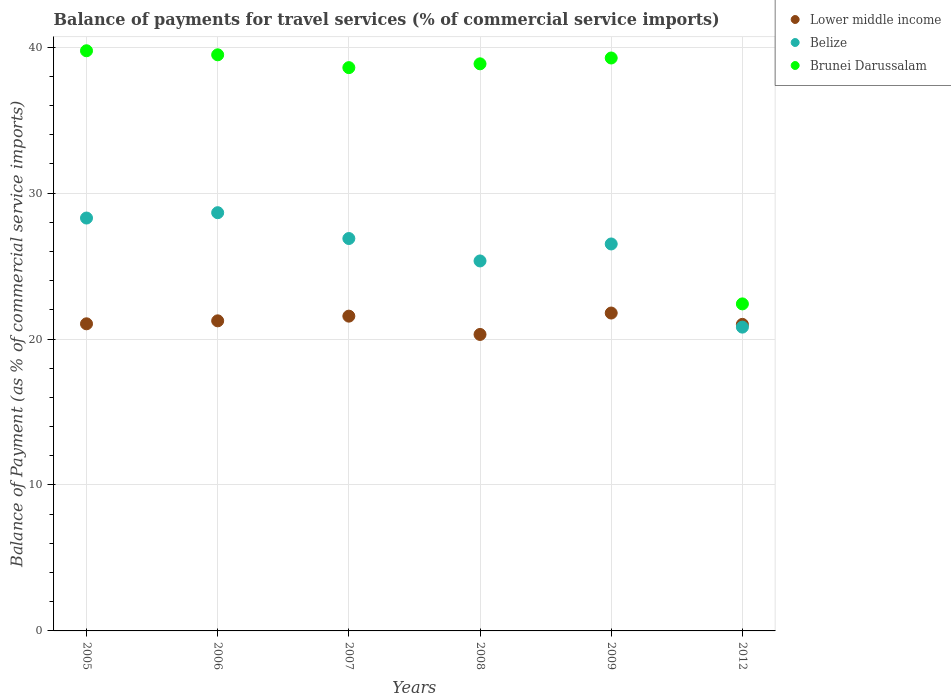How many different coloured dotlines are there?
Make the answer very short. 3. What is the balance of payments for travel services in Brunei Darussalam in 2012?
Offer a terse response. 22.41. Across all years, what is the maximum balance of payments for travel services in Belize?
Your response must be concise. 28.66. Across all years, what is the minimum balance of payments for travel services in Lower middle income?
Provide a short and direct response. 20.31. In which year was the balance of payments for travel services in Brunei Darussalam minimum?
Give a very brief answer. 2012. What is the total balance of payments for travel services in Lower middle income in the graph?
Ensure brevity in your answer.  126.95. What is the difference between the balance of payments for travel services in Lower middle income in 2005 and that in 2008?
Your answer should be very brief. 0.73. What is the difference between the balance of payments for travel services in Brunei Darussalam in 2005 and the balance of payments for travel services in Belize in 2009?
Your answer should be very brief. 13.24. What is the average balance of payments for travel services in Brunei Darussalam per year?
Provide a succinct answer. 36.39. In the year 2009, what is the difference between the balance of payments for travel services in Belize and balance of payments for travel services in Lower middle income?
Give a very brief answer. 4.73. In how many years, is the balance of payments for travel services in Lower middle income greater than 26 %?
Offer a terse response. 0. What is the ratio of the balance of payments for travel services in Brunei Darussalam in 2005 to that in 2009?
Offer a terse response. 1.01. Is the balance of payments for travel services in Lower middle income in 2007 less than that in 2012?
Your answer should be very brief. No. What is the difference between the highest and the second highest balance of payments for travel services in Belize?
Ensure brevity in your answer.  0.37. What is the difference between the highest and the lowest balance of payments for travel services in Belize?
Keep it short and to the point. 7.84. In how many years, is the balance of payments for travel services in Brunei Darussalam greater than the average balance of payments for travel services in Brunei Darussalam taken over all years?
Keep it short and to the point. 5. Is the sum of the balance of payments for travel services in Lower middle income in 2007 and 2008 greater than the maximum balance of payments for travel services in Belize across all years?
Ensure brevity in your answer.  Yes. Is the balance of payments for travel services in Belize strictly greater than the balance of payments for travel services in Brunei Darussalam over the years?
Offer a very short reply. No. Is the balance of payments for travel services in Lower middle income strictly less than the balance of payments for travel services in Belize over the years?
Make the answer very short. No. How many years are there in the graph?
Your response must be concise. 6. Does the graph contain any zero values?
Your response must be concise. No. Does the graph contain grids?
Give a very brief answer. Yes. Where does the legend appear in the graph?
Offer a very short reply. Top right. What is the title of the graph?
Offer a very short reply. Balance of payments for travel services (% of commercial service imports). Does "Switzerland" appear as one of the legend labels in the graph?
Give a very brief answer. No. What is the label or title of the Y-axis?
Provide a succinct answer. Balance of Payment (as % of commercial service imports). What is the Balance of Payment (as % of commercial service imports) of Lower middle income in 2005?
Offer a terse response. 21.04. What is the Balance of Payment (as % of commercial service imports) in Belize in 2005?
Provide a short and direct response. 28.29. What is the Balance of Payment (as % of commercial service imports) of Brunei Darussalam in 2005?
Make the answer very short. 39.75. What is the Balance of Payment (as % of commercial service imports) of Lower middle income in 2006?
Your answer should be very brief. 21.25. What is the Balance of Payment (as % of commercial service imports) of Belize in 2006?
Your answer should be very brief. 28.66. What is the Balance of Payment (as % of commercial service imports) of Brunei Darussalam in 2006?
Ensure brevity in your answer.  39.47. What is the Balance of Payment (as % of commercial service imports) in Lower middle income in 2007?
Keep it short and to the point. 21.57. What is the Balance of Payment (as % of commercial service imports) in Belize in 2007?
Your response must be concise. 26.89. What is the Balance of Payment (as % of commercial service imports) in Brunei Darussalam in 2007?
Keep it short and to the point. 38.59. What is the Balance of Payment (as % of commercial service imports) of Lower middle income in 2008?
Provide a short and direct response. 20.31. What is the Balance of Payment (as % of commercial service imports) of Belize in 2008?
Ensure brevity in your answer.  25.35. What is the Balance of Payment (as % of commercial service imports) in Brunei Darussalam in 2008?
Your answer should be compact. 38.86. What is the Balance of Payment (as % of commercial service imports) in Lower middle income in 2009?
Ensure brevity in your answer.  21.78. What is the Balance of Payment (as % of commercial service imports) in Belize in 2009?
Give a very brief answer. 26.51. What is the Balance of Payment (as % of commercial service imports) in Brunei Darussalam in 2009?
Your answer should be very brief. 39.25. What is the Balance of Payment (as % of commercial service imports) of Lower middle income in 2012?
Provide a succinct answer. 21. What is the Balance of Payment (as % of commercial service imports) of Belize in 2012?
Give a very brief answer. 20.82. What is the Balance of Payment (as % of commercial service imports) in Brunei Darussalam in 2012?
Your answer should be compact. 22.41. Across all years, what is the maximum Balance of Payment (as % of commercial service imports) in Lower middle income?
Make the answer very short. 21.78. Across all years, what is the maximum Balance of Payment (as % of commercial service imports) in Belize?
Provide a succinct answer. 28.66. Across all years, what is the maximum Balance of Payment (as % of commercial service imports) in Brunei Darussalam?
Your response must be concise. 39.75. Across all years, what is the minimum Balance of Payment (as % of commercial service imports) of Lower middle income?
Ensure brevity in your answer.  20.31. Across all years, what is the minimum Balance of Payment (as % of commercial service imports) in Belize?
Keep it short and to the point. 20.82. Across all years, what is the minimum Balance of Payment (as % of commercial service imports) of Brunei Darussalam?
Keep it short and to the point. 22.41. What is the total Balance of Payment (as % of commercial service imports) in Lower middle income in the graph?
Offer a terse response. 126.95. What is the total Balance of Payment (as % of commercial service imports) in Belize in the graph?
Your response must be concise. 156.51. What is the total Balance of Payment (as % of commercial service imports) of Brunei Darussalam in the graph?
Offer a terse response. 218.34. What is the difference between the Balance of Payment (as % of commercial service imports) of Lower middle income in 2005 and that in 2006?
Ensure brevity in your answer.  -0.2. What is the difference between the Balance of Payment (as % of commercial service imports) in Belize in 2005 and that in 2006?
Make the answer very short. -0.37. What is the difference between the Balance of Payment (as % of commercial service imports) of Brunei Darussalam in 2005 and that in 2006?
Keep it short and to the point. 0.28. What is the difference between the Balance of Payment (as % of commercial service imports) of Lower middle income in 2005 and that in 2007?
Provide a short and direct response. -0.53. What is the difference between the Balance of Payment (as % of commercial service imports) in Belize in 2005 and that in 2007?
Your response must be concise. 1.4. What is the difference between the Balance of Payment (as % of commercial service imports) in Brunei Darussalam in 2005 and that in 2007?
Your answer should be compact. 1.16. What is the difference between the Balance of Payment (as % of commercial service imports) in Lower middle income in 2005 and that in 2008?
Provide a succinct answer. 0.73. What is the difference between the Balance of Payment (as % of commercial service imports) of Belize in 2005 and that in 2008?
Your answer should be very brief. 2.94. What is the difference between the Balance of Payment (as % of commercial service imports) in Brunei Darussalam in 2005 and that in 2008?
Ensure brevity in your answer.  0.9. What is the difference between the Balance of Payment (as % of commercial service imports) in Lower middle income in 2005 and that in 2009?
Your answer should be compact. -0.74. What is the difference between the Balance of Payment (as % of commercial service imports) in Belize in 2005 and that in 2009?
Keep it short and to the point. 1.78. What is the difference between the Balance of Payment (as % of commercial service imports) of Brunei Darussalam in 2005 and that in 2009?
Provide a short and direct response. 0.5. What is the difference between the Balance of Payment (as % of commercial service imports) in Lower middle income in 2005 and that in 2012?
Your answer should be very brief. 0.04. What is the difference between the Balance of Payment (as % of commercial service imports) of Belize in 2005 and that in 2012?
Give a very brief answer. 7.47. What is the difference between the Balance of Payment (as % of commercial service imports) in Brunei Darussalam in 2005 and that in 2012?
Make the answer very short. 17.34. What is the difference between the Balance of Payment (as % of commercial service imports) in Lower middle income in 2006 and that in 2007?
Your answer should be very brief. -0.32. What is the difference between the Balance of Payment (as % of commercial service imports) of Belize in 2006 and that in 2007?
Provide a succinct answer. 1.77. What is the difference between the Balance of Payment (as % of commercial service imports) of Brunei Darussalam in 2006 and that in 2007?
Ensure brevity in your answer.  0.88. What is the difference between the Balance of Payment (as % of commercial service imports) in Lower middle income in 2006 and that in 2008?
Keep it short and to the point. 0.93. What is the difference between the Balance of Payment (as % of commercial service imports) in Belize in 2006 and that in 2008?
Offer a very short reply. 3.31. What is the difference between the Balance of Payment (as % of commercial service imports) in Brunei Darussalam in 2006 and that in 2008?
Offer a terse response. 0.62. What is the difference between the Balance of Payment (as % of commercial service imports) of Lower middle income in 2006 and that in 2009?
Keep it short and to the point. -0.53. What is the difference between the Balance of Payment (as % of commercial service imports) of Belize in 2006 and that in 2009?
Offer a terse response. 2.14. What is the difference between the Balance of Payment (as % of commercial service imports) in Brunei Darussalam in 2006 and that in 2009?
Keep it short and to the point. 0.22. What is the difference between the Balance of Payment (as % of commercial service imports) in Lower middle income in 2006 and that in 2012?
Offer a very short reply. 0.24. What is the difference between the Balance of Payment (as % of commercial service imports) of Belize in 2006 and that in 2012?
Make the answer very short. 7.84. What is the difference between the Balance of Payment (as % of commercial service imports) in Brunei Darussalam in 2006 and that in 2012?
Keep it short and to the point. 17.07. What is the difference between the Balance of Payment (as % of commercial service imports) of Lower middle income in 2007 and that in 2008?
Ensure brevity in your answer.  1.25. What is the difference between the Balance of Payment (as % of commercial service imports) in Belize in 2007 and that in 2008?
Offer a terse response. 1.54. What is the difference between the Balance of Payment (as % of commercial service imports) of Brunei Darussalam in 2007 and that in 2008?
Ensure brevity in your answer.  -0.26. What is the difference between the Balance of Payment (as % of commercial service imports) in Lower middle income in 2007 and that in 2009?
Ensure brevity in your answer.  -0.21. What is the difference between the Balance of Payment (as % of commercial service imports) of Belize in 2007 and that in 2009?
Offer a terse response. 0.37. What is the difference between the Balance of Payment (as % of commercial service imports) in Brunei Darussalam in 2007 and that in 2009?
Your answer should be compact. -0.66. What is the difference between the Balance of Payment (as % of commercial service imports) in Lower middle income in 2007 and that in 2012?
Your answer should be compact. 0.56. What is the difference between the Balance of Payment (as % of commercial service imports) in Belize in 2007 and that in 2012?
Provide a short and direct response. 6.07. What is the difference between the Balance of Payment (as % of commercial service imports) of Brunei Darussalam in 2007 and that in 2012?
Make the answer very short. 16.19. What is the difference between the Balance of Payment (as % of commercial service imports) of Lower middle income in 2008 and that in 2009?
Keep it short and to the point. -1.47. What is the difference between the Balance of Payment (as % of commercial service imports) of Belize in 2008 and that in 2009?
Ensure brevity in your answer.  -1.16. What is the difference between the Balance of Payment (as % of commercial service imports) in Brunei Darussalam in 2008 and that in 2009?
Provide a short and direct response. -0.4. What is the difference between the Balance of Payment (as % of commercial service imports) in Lower middle income in 2008 and that in 2012?
Offer a very short reply. -0.69. What is the difference between the Balance of Payment (as % of commercial service imports) in Belize in 2008 and that in 2012?
Offer a terse response. 4.53. What is the difference between the Balance of Payment (as % of commercial service imports) of Brunei Darussalam in 2008 and that in 2012?
Your response must be concise. 16.45. What is the difference between the Balance of Payment (as % of commercial service imports) in Lower middle income in 2009 and that in 2012?
Your answer should be very brief. 0.78. What is the difference between the Balance of Payment (as % of commercial service imports) of Belize in 2009 and that in 2012?
Give a very brief answer. 5.7. What is the difference between the Balance of Payment (as % of commercial service imports) of Brunei Darussalam in 2009 and that in 2012?
Your answer should be very brief. 16.85. What is the difference between the Balance of Payment (as % of commercial service imports) of Lower middle income in 2005 and the Balance of Payment (as % of commercial service imports) of Belize in 2006?
Provide a succinct answer. -7.61. What is the difference between the Balance of Payment (as % of commercial service imports) in Lower middle income in 2005 and the Balance of Payment (as % of commercial service imports) in Brunei Darussalam in 2006?
Your response must be concise. -18.43. What is the difference between the Balance of Payment (as % of commercial service imports) of Belize in 2005 and the Balance of Payment (as % of commercial service imports) of Brunei Darussalam in 2006?
Make the answer very short. -11.18. What is the difference between the Balance of Payment (as % of commercial service imports) of Lower middle income in 2005 and the Balance of Payment (as % of commercial service imports) of Belize in 2007?
Your response must be concise. -5.84. What is the difference between the Balance of Payment (as % of commercial service imports) in Lower middle income in 2005 and the Balance of Payment (as % of commercial service imports) in Brunei Darussalam in 2007?
Your answer should be compact. -17.55. What is the difference between the Balance of Payment (as % of commercial service imports) in Belize in 2005 and the Balance of Payment (as % of commercial service imports) in Brunei Darussalam in 2007?
Give a very brief answer. -10.31. What is the difference between the Balance of Payment (as % of commercial service imports) of Lower middle income in 2005 and the Balance of Payment (as % of commercial service imports) of Belize in 2008?
Your answer should be compact. -4.31. What is the difference between the Balance of Payment (as % of commercial service imports) in Lower middle income in 2005 and the Balance of Payment (as % of commercial service imports) in Brunei Darussalam in 2008?
Offer a very short reply. -17.81. What is the difference between the Balance of Payment (as % of commercial service imports) in Belize in 2005 and the Balance of Payment (as % of commercial service imports) in Brunei Darussalam in 2008?
Offer a very short reply. -10.57. What is the difference between the Balance of Payment (as % of commercial service imports) in Lower middle income in 2005 and the Balance of Payment (as % of commercial service imports) in Belize in 2009?
Provide a succinct answer. -5.47. What is the difference between the Balance of Payment (as % of commercial service imports) of Lower middle income in 2005 and the Balance of Payment (as % of commercial service imports) of Brunei Darussalam in 2009?
Provide a succinct answer. -18.21. What is the difference between the Balance of Payment (as % of commercial service imports) in Belize in 2005 and the Balance of Payment (as % of commercial service imports) in Brunei Darussalam in 2009?
Your response must be concise. -10.97. What is the difference between the Balance of Payment (as % of commercial service imports) in Lower middle income in 2005 and the Balance of Payment (as % of commercial service imports) in Belize in 2012?
Offer a very short reply. 0.23. What is the difference between the Balance of Payment (as % of commercial service imports) of Lower middle income in 2005 and the Balance of Payment (as % of commercial service imports) of Brunei Darussalam in 2012?
Ensure brevity in your answer.  -1.36. What is the difference between the Balance of Payment (as % of commercial service imports) in Belize in 2005 and the Balance of Payment (as % of commercial service imports) in Brunei Darussalam in 2012?
Make the answer very short. 5.88. What is the difference between the Balance of Payment (as % of commercial service imports) of Lower middle income in 2006 and the Balance of Payment (as % of commercial service imports) of Belize in 2007?
Your answer should be compact. -5.64. What is the difference between the Balance of Payment (as % of commercial service imports) in Lower middle income in 2006 and the Balance of Payment (as % of commercial service imports) in Brunei Darussalam in 2007?
Ensure brevity in your answer.  -17.35. What is the difference between the Balance of Payment (as % of commercial service imports) in Belize in 2006 and the Balance of Payment (as % of commercial service imports) in Brunei Darussalam in 2007?
Your response must be concise. -9.94. What is the difference between the Balance of Payment (as % of commercial service imports) of Lower middle income in 2006 and the Balance of Payment (as % of commercial service imports) of Belize in 2008?
Your answer should be compact. -4.1. What is the difference between the Balance of Payment (as % of commercial service imports) of Lower middle income in 2006 and the Balance of Payment (as % of commercial service imports) of Brunei Darussalam in 2008?
Offer a very short reply. -17.61. What is the difference between the Balance of Payment (as % of commercial service imports) in Belize in 2006 and the Balance of Payment (as % of commercial service imports) in Brunei Darussalam in 2008?
Give a very brief answer. -10.2. What is the difference between the Balance of Payment (as % of commercial service imports) of Lower middle income in 2006 and the Balance of Payment (as % of commercial service imports) of Belize in 2009?
Offer a very short reply. -5.27. What is the difference between the Balance of Payment (as % of commercial service imports) in Lower middle income in 2006 and the Balance of Payment (as % of commercial service imports) in Brunei Darussalam in 2009?
Your answer should be compact. -18.01. What is the difference between the Balance of Payment (as % of commercial service imports) of Belize in 2006 and the Balance of Payment (as % of commercial service imports) of Brunei Darussalam in 2009?
Your response must be concise. -10.6. What is the difference between the Balance of Payment (as % of commercial service imports) in Lower middle income in 2006 and the Balance of Payment (as % of commercial service imports) in Belize in 2012?
Your response must be concise. 0.43. What is the difference between the Balance of Payment (as % of commercial service imports) of Lower middle income in 2006 and the Balance of Payment (as % of commercial service imports) of Brunei Darussalam in 2012?
Provide a succinct answer. -1.16. What is the difference between the Balance of Payment (as % of commercial service imports) in Belize in 2006 and the Balance of Payment (as % of commercial service imports) in Brunei Darussalam in 2012?
Offer a terse response. 6.25. What is the difference between the Balance of Payment (as % of commercial service imports) in Lower middle income in 2007 and the Balance of Payment (as % of commercial service imports) in Belize in 2008?
Make the answer very short. -3.78. What is the difference between the Balance of Payment (as % of commercial service imports) of Lower middle income in 2007 and the Balance of Payment (as % of commercial service imports) of Brunei Darussalam in 2008?
Your answer should be compact. -17.29. What is the difference between the Balance of Payment (as % of commercial service imports) of Belize in 2007 and the Balance of Payment (as % of commercial service imports) of Brunei Darussalam in 2008?
Ensure brevity in your answer.  -11.97. What is the difference between the Balance of Payment (as % of commercial service imports) of Lower middle income in 2007 and the Balance of Payment (as % of commercial service imports) of Belize in 2009?
Provide a succinct answer. -4.95. What is the difference between the Balance of Payment (as % of commercial service imports) in Lower middle income in 2007 and the Balance of Payment (as % of commercial service imports) in Brunei Darussalam in 2009?
Give a very brief answer. -17.69. What is the difference between the Balance of Payment (as % of commercial service imports) of Belize in 2007 and the Balance of Payment (as % of commercial service imports) of Brunei Darussalam in 2009?
Your answer should be very brief. -12.37. What is the difference between the Balance of Payment (as % of commercial service imports) of Lower middle income in 2007 and the Balance of Payment (as % of commercial service imports) of Belize in 2012?
Provide a succinct answer. 0.75. What is the difference between the Balance of Payment (as % of commercial service imports) of Lower middle income in 2007 and the Balance of Payment (as % of commercial service imports) of Brunei Darussalam in 2012?
Provide a short and direct response. -0.84. What is the difference between the Balance of Payment (as % of commercial service imports) in Belize in 2007 and the Balance of Payment (as % of commercial service imports) in Brunei Darussalam in 2012?
Keep it short and to the point. 4.48. What is the difference between the Balance of Payment (as % of commercial service imports) in Lower middle income in 2008 and the Balance of Payment (as % of commercial service imports) in Belize in 2009?
Your answer should be compact. -6.2. What is the difference between the Balance of Payment (as % of commercial service imports) in Lower middle income in 2008 and the Balance of Payment (as % of commercial service imports) in Brunei Darussalam in 2009?
Make the answer very short. -18.94. What is the difference between the Balance of Payment (as % of commercial service imports) in Belize in 2008 and the Balance of Payment (as % of commercial service imports) in Brunei Darussalam in 2009?
Your response must be concise. -13.9. What is the difference between the Balance of Payment (as % of commercial service imports) in Lower middle income in 2008 and the Balance of Payment (as % of commercial service imports) in Belize in 2012?
Ensure brevity in your answer.  -0.5. What is the difference between the Balance of Payment (as % of commercial service imports) in Lower middle income in 2008 and the Balance of Payment (as % of commercial service imports) in Brunei Darussalam in 2012?
Your answer should be very brief. -2.09. What is the difference between the Balance of Payment (as % of commercial service imports) of Belize in 2008 and the Balance of Payment (as % of commercial service imports) of Brunei Darussalam in 2012?
Give a very brief answer. 2.94. What is the difference between the Balance of Payment (as % of commercial service imports) in Lower middle income in 2009 and the Balance of Payment (as % of commercial service imports) in Belize in 2012?
Provide a short and direct response. 0.96. What is the difference between the Balance of Payment (as % of commercial service imports) in Lower middle income in 2009 and the Balance of Payment (as % of commercial service imports) in Brunei Darussalam in 2012?
Provide a short and direct response. -0.63. What is the difference between the Balance of Payment (as % of commercial service imports) of Belize in 2009 and the Balance of Payment (as % of commercial service imports) of Brunei Darussalam in 2012?
Offer a terse response. 4.11. What is the average Balance of Payment (as % of commercial service imports) in Lower middle income per year?
Offer a terse response. 21.16. What is the average Balance of Payment (as % of commercial service imports) in Belize per year?
Make the answer very short. 26.08. What is the average Balance of Payment (as % of commercial service imports) in Brunei Darussalam per year?
Your answer should be compact. 36.39. In the year 2005, what is the difference between the Balance of Payment (as % of commercial service imports) of Lower middle income and Balance of Payment (as % of commercial service imports) of Belize?
Your response must be concise. -7.25. In the year 2005, what is the difference between the Balance of Payment (as % of commercial service imports) of Lower middle income and Balance of Payment (as % of commercial service imports) of Brunei Darussalam?
Offer a terse response. -18.71. In the year 2005, what is the difference between the Balance of Payment (as % of commercial service imports) of Belize and Balance of Payment (as % of commercial service imports) of Brunei Darussalam?
Give a very brief answer. -11.46. In the year 2006, what is the difference between the Balance of Payment (as % of commercial service imports) in Lower middle income and Balance of Payment (as % of commercial service imports) in Belize?
Make the answer very short. -7.41. In the year 2006, what is the difference between the Balance of Payment (as % of commercial service imports) of Lower middle income and Balance of Payment (as % of commercial service imports) of Brunei Darussalam?
Provide a short and direct response. -18.23. In the year 2006, what is the difference between the Balance of Payment (as % of commercial service imports) of Belize and Balance of Payment (as % of commercial service imports) of Brunei Darussalam?
Provide a short and direct response. -10.82. In the year 2007, what is the difference between the Balance of Payment (as % of commercial service imports) of Lower middle income and Balance of Payment (as % of commercial service imports) of Belize?
Provide a short and direct response. -5.32. In the year 2007, what is the difference between the Balance of Payment (as % of commercial service imports) in Lower middle income and Balance of Payment (as % of commercial service imports) in Brunei Darussalam?
Provide a short and direct response. -17.03. In the year 2007, what is the difference between the Balance of Payment (as % of commercial service imports) in Belize and Balance of Payment (as % of commercial service imports) in Brunei Darussalam?
Provide a short and direct response. -11.71. In the year 2008, what is the difference between the Balance of Payment (as % of commercial service imports) in Lower middle income and Balance of Payment (as % of commercial service imports) in Belize?
Your answer should be very brief. -5.04. In the year 2008, what is the difference between the Balance of Payment (as % of commercial service imports) in Lower middle income and Balance of Payment (as % of commercial service imports) in Brunei Darussalam?
Your answer should be compact. -18.54. In the year 2008, what is the difference between the Balance of Payment (as % of commercial service imports) in Belize and Balance of Payment (as % of commercial service imports) in Brunei Darussalam?
Keep it short and to the point. -13.51. In the year 2009, what is the difference between the Balance of Payment (as % of commercial service imports) of Lower middle income and Balance of Payment (as % of commercial service imports) of Belize?
Your answer should be compact. -4.73. In the year 2009, what is the difference between the Balance of Payment (as % of commercial service imports) of Lower middle income and Balance of Payment (as % of commercial service imports) of Brunei Darussalam?
Your response must be concise. -17.47. In the year 2009, what is the difference between the Balance of Payment (as % of commercial service imports) in Belize and Balance of Payment (as % of commercial service imports) in Brunei Darussalam?
Ensure brevity in your answer.  -12.74. In the year 2012, what is the difference between the Balance of Payment (as % of commercial service imports) of Lower middle income and Balance of Payment (as % of commercial service imports) of Belize?
Your answer should be very brief. 0.19. In the year 2012, what is the difference between the Balance of Payment (as % of commercial service imports) of Lower middle income and Balance of Payment (as % of commercial service imports) of Brunei Darussalam?
Provide a short and direct response. -1.4. In the year 2012, what is the difference between the Balance of Payment (as % of commercial service imports) of Belize and Balance of Payment (as % of commercial service imports) of Brunei Darussalam?
Make the answer very short. -1.59. What is the ratio of the Balance of Payment (as % of commercial service imports) in Lower middle income in 2005 to that in 2006?
Provide a short and direct response. 0.99. What is the ratio of the Balance of Payment (as % of commercial service imports) of Belize in 2005 to that in 2006?
Make the answer very short. 0.99. What is the ratio of the Balance of Payment (as % of commercial service imports) of Brunei Darussalam in 2005 to that in 2006?
Offer a very short reply. 1.01. What is the ratio of the Balance of Payment (as % of commercial service imports) of Lower middle income in 2005 to that in 2007?
Your response must be concise. 0.98. What is the ratio of the Balance of Payment (as % of commercial service imports) of Belize in 2005 to that in 2007?
Provide a succinct answer. 1.05. What is the ratio of the Balance of Payment (as % of commercial service imports) in Brunei Darussalam in 2005 to that in 2007?
Give a very brief answer. 1.03. What is the ratio of the Balance of Payment (as % of commercial service imports) of Lower middle income in 2005 to that in 2008?
Your answer should be compact. 1.04. What is the ratio of the Balance of Payment (as % of commercial service imports) of Belize in 2005 to that in 2008?
Give a very brief answer. 1.12. What is the ratio of the Balance of Payment (as % of commercial service imports) in Brunei Darussalam in 2005 to that in 2008?
Ensure brevity in your answer.  1.02. What is the ratio of the Balance of Payment (as % of commercial service imports) in Lower middle income in 2005 to that in 2009?
Provide a succinct answer. 0.97. What is the ratio of the Balance of Payment (as % of commercial service imports) of Belize in 2005 to that in 2009?
Your response must be concise. 1.07. What is the ratio of the Balance of Payment (as % of commercial service imports) in Brunei Darussalam in 2005 to that in 2009?
Offer a terse response. 1.01. What is the ratio of the Balance of Payment (as % of commercial service imports) of Lower middle income in 2005 to that in 2012?
Offer a terse response. 1. What is the ratio of the Balance of Payment (as % of commercial service imports) of Belize in 2005 to that in 2012?
Give a very brief answer. 1.36. What is the ratio of the Balance of Payment (as % of commercial service imports) in Brunei Darussalam in 2005 to that in 2012?
Make the answer very short. 1.77. What is the ratio of the Balance of Payment (as % of commercial service imports) of Lower middle income in 2006 to that in 2007?
Give a very brief answer. 0.99. What is the ratio of the Balance of Payment (as % of commercial service imports) in Belize in 2006 to that in 2007?
Provide a succinct answer. 1.07. What is the ratio of the Balance of Payment (as % of commercial service imports) of Brunei Darussalam in 2006 to that in 2007?
Your answer should be very brief. 1.02. What is the ratio of the Balance of Payment (as % of commercial service imports) in Lower middle income in 2006 to that in 2008?
Provide a succinct answer. 1.05. What is the ratio of the Balance of Payment (as % of commercial service imports) of Belize in 2006 to that in 2008?
Ensure brevity in your answer.  1.13. What is the ratio of the Balance of Payment (as % of commercial service imports) of Brunei Darussalam in 2006 to that in 2008?
Offer a terse response. 1.02. What is the ratio of the Balance of Payment (as % of commercial service imports) in Lower middle income in 2006 to that in 2009?
Your answer should be very brief. 0.98. What is the ratio of the Balance of Payment (as % of commercial service imports) of Belize in 2006 to that in 2009?
Give a very brief answer. 1.08. What is the ratio of the Balance of Payment (as % of commercial service imports) in Brunei Darussalam in 2006 to that in 2009?
Offer a terse response. 1.01. What is the ratio of the Balance of Payment (as % of commercial service imports) in Lower middle income in 2006 to that in 2012?
Keep it short and to the point. 1.01. What is the ratio of the Balance of Payment (as % of commercial service imports) in Belize in 2006 to that in 2012?
Your response must be concise. 1.38. What is the ratio of the Balance of Payment (as % of commercial service imports) in Brunei Darussalam in 2006 to that in 2012?
Your answer should be compact. 1.76. What is the ratio of the Balance of Payment (as % of commercial service imports) of Lower middle income in 2007 to that in 2008?
Make the answer very short. 1.06. What is the ratio of the Balance of Payment (as % of commercial service imports) of Belize in 2007 to that in 2008?
Your answer should be compact. 1.06. What is the ratio of the Balance of Payment (as % of commercial service imports) of Brunei Darussalam in 2007 to that in 2008?
Offer a terse response. 0.99. What is the ratio of the Balance of Payment (as % of commercial service imports) in Lower middle income in 2007 to that in 2009?
Provide a succinct answer. 0.99. What is the ratio of the Balance of Payment (as % of commercial service imports) in Belize in 2007 to that in 2009?
Give a very brief answer. 1.01. What is the ratio of the Balance of Payment (as % of commercial service imports) in Brunei Darussalam in 2007 to that in 2009?
Offer a very short reply. 0.98. What is the ratio of the Balance of Payment (as % of commercial service imports) in Lower middle income in 2007 to that in 2012?
Your answer should be very brief. 1.03. What is the ratio of the Balance of Payment (as % of commercial service imports) of Belize in 2007 to that in 2012?
Your answer should be very brief. 1.29. What is the ratio of the Balance of Payment (as % of commercial service imports) of Brunei Darussalam in 2007 to that in 2012?
Provide a short and direct response. 1.72. What is the ratio of the Balance of Payment (as % of commercial service imports) of Lower middle income in 2008 to that in 2009?
Keep it short and to the point. 0.93. What is the ratio of the Balance of Payment (as % of commercial service imports) in Belize in 2008 to that in 2009?
Offer a very short reply. 0.96. What is the ratio of the Balance of Payment (as % of commercial service imports) in Lower middle income in 2008 to that in 2012?
Make the answer very short. 0.97. What is the ratio of the Balance of Payment (as % of commercial service imports) of Belize in 2008 to that in 2012?
Provide a short and direct response. 1.22. What is the ratio of the Balance of Payment (as % of commercial service imports) in Brunei Darussalam in 2008 to that in 2012?
Your answer should be compact. 1.73. What is the ratio of the Balance of Payment (as % of commercial service imports) of Lower middle income in 2009 to that in 2012?
Provide a succinct answer. 1.04. What is the ratio of the Balance of Payment (as % of commercial service imports) in Belize in 2009 to that in 2012?
Keep it short and to the point. 1.27. What is the ratio of the Balance of Payment (as % of commercial service imports) of Brunei Darussalam in 2009 to that in 2012?
Provide a short and direct response. 1.75. What is the difference between the highest and the second highest Balance of Payment (as % of commercial service imports) of Lower middle income?
Your answer should be compact. 0.21. What is the difference between the highest and the second highest Balance of Payment (as % of commercial service imports) in Belize?
Offer a very short reply. 0.37. What is the difference between the highest and the second highest Balance of Payment (as % of commercial service imports) of Brunei Darussalam?
Your answer should be compact. 0.28. What is the difference between the highest and the lowest Balance of Payment (as % of commercial service imports) of Lower middle income?
Offer a very short reply. 1.47. What is the difference between the highest and the lowest Balance of Payment (as % of commercial service imports) of Belize?
Give a very brief answer. 7.84. What is the difference between the highest and the lowest Balance of Payment (as % of commercial service imports) in Brunei Darussalam?
Your response must be concise. 17.34. 